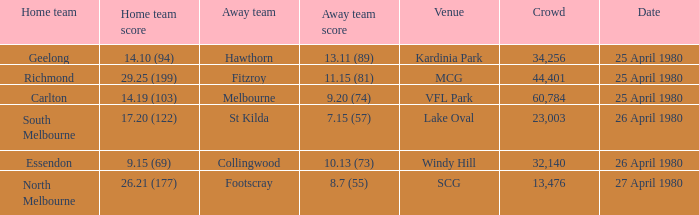What was the lowest crowd size at MCG? 44401.0. 